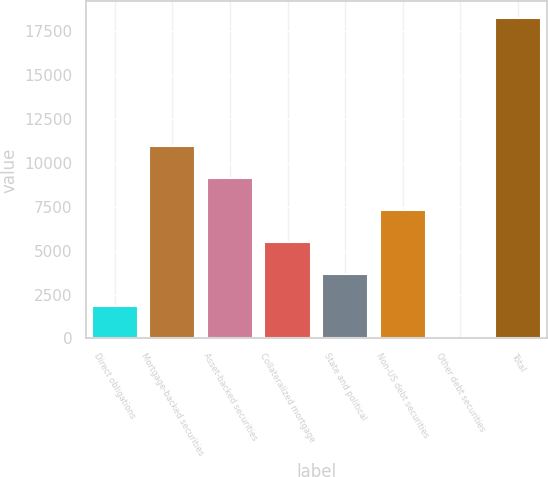<chart> <loc_0><loc_0><loc_500><loc_500><bar_chart><fcel>Direct obligations<fcel>Mortgage-backed securities<fcel>Asset-backed securities<fcel>Collateralized mortgage<fcel>State and political<fcel>Non-US debt securities<fcel>Other debt securities<fcel>Total<nl><fcel>1859.9<fcel>10989.4<fcel>9163.5<fcel>5511.7<fcel>3685.8<fcel>7337.6<fcel>34<fcel>18293<nl></chart> 